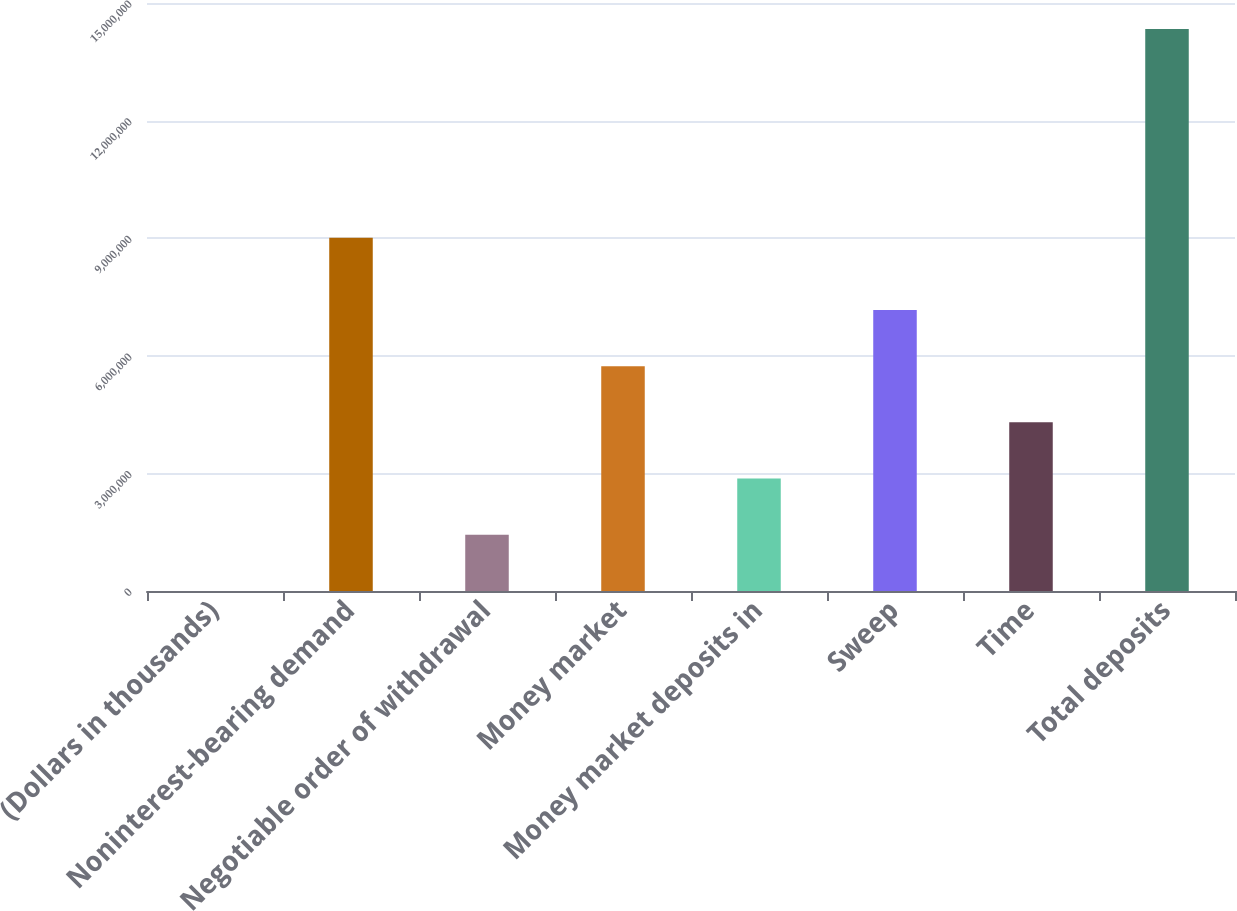Convert chart to OTSL. <chart><loc_0><loc_0><loc_500><loc_500><bar_chart><fcel>(Dollars in thousands)<fcel>Noninterest-bearing demand<fcel>Negotiable order of withdrawal<fcel>Money market<fcel>Money market deposits in<fcel>Sweep<fcel>Time<fcel>Total deposits<nl><fcel>2010<fcel>9.01154e+06<fcel>1.4355e+06<fcel>5.73598e+06<fcel>2.869e+06<fcel>7.16948e+06<fcel>4.30249e+06<fcel>1.43369e+07<nl></chart> 